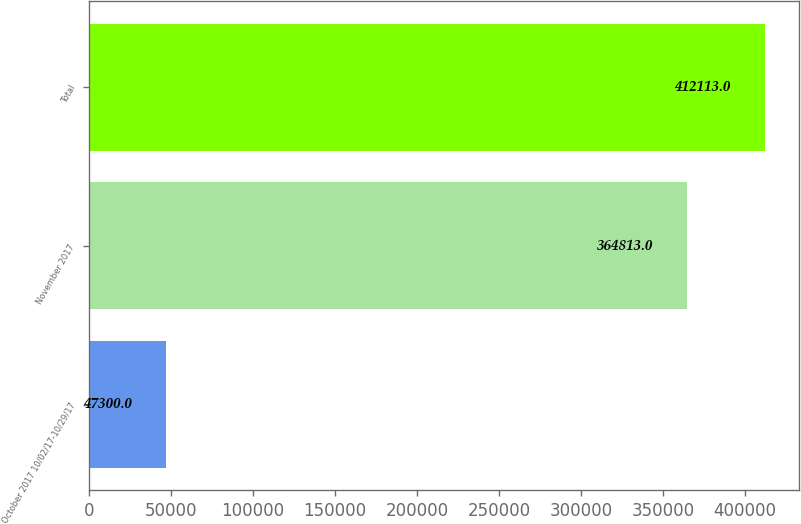Convert chart. <chart><loc_0><loc_0><loc_500><loc_500><bar_chart><fcel>October 2017 10/02/17-10/29/17<fcel>November 2017<fcel>Total<nl><fcel>47300<fcel>364813<fcel>412113<nl></chart> 